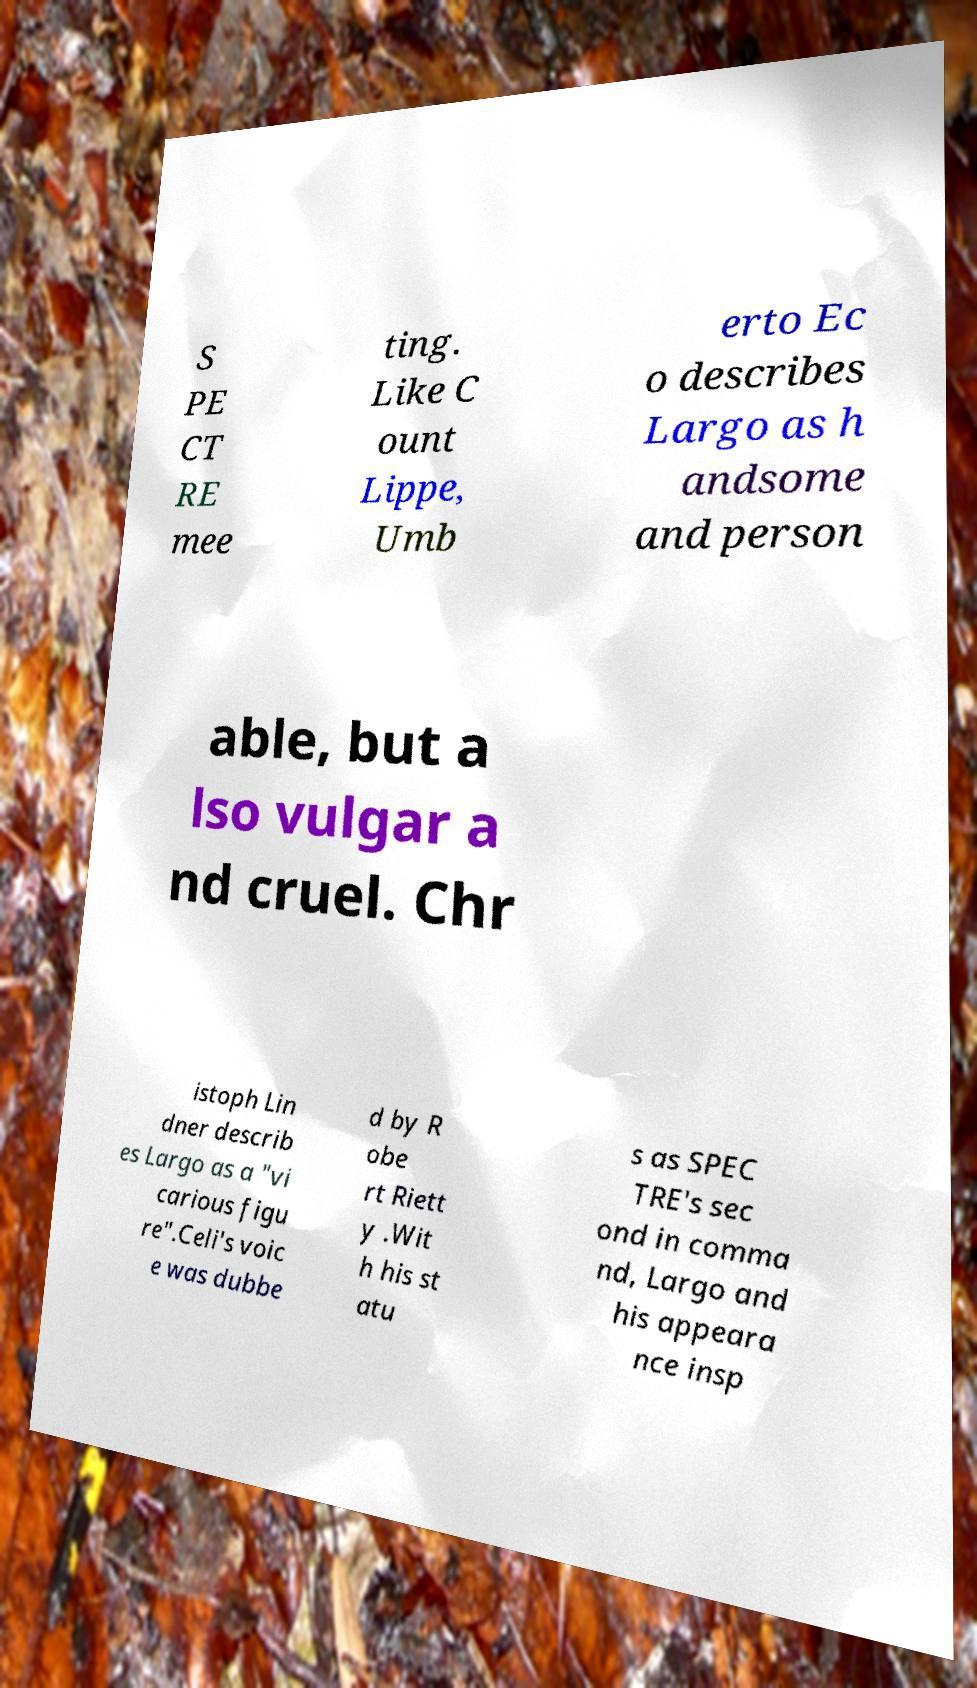Please read and relay the text visible in this image. What does it say? S PE CT RE mee ting. Like C ount Lippe, Umb erto Ec o describes Largo as h andsome and person able, but a lso vulgar a nd cruel. Chr istoph Lin dner describ es Largo as a "vi carious figu re".Celi's voic e was dubbe d by R obe rt Riett y .Wit h his st atu s as SPEC TRE's sec ond in comma nd, Largo and his appeara nce insp 